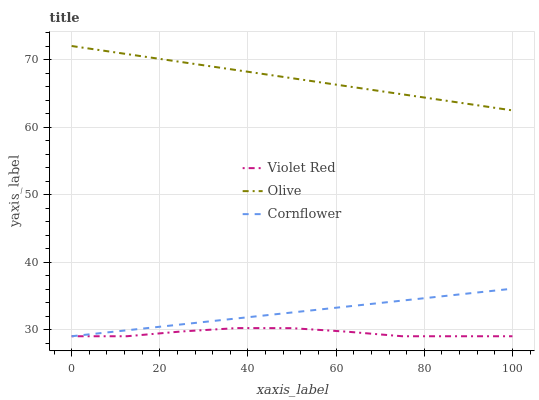Does Violet Red have the minimum area under the curve?
Answer yes or no. Yes. Does Olive have the maximum area under the curve?
Answer yes or no. Yes. Does Cornflower have the minimum area under the curve?
Answer yes or no. No. Does Cornflower have the maximum area under the curve?
Answer yes or no. No. Is Olive the smoothest?
Answer yes or no. Yes. Is Violet Red the roughest?
Answer yes or no. Yes. Is Violet Red the smoothest?
Answer yes or no. No. Is Cornflower the roughest?
Answer yes or no. No. Does Cornflower have the lowest value?
Answer yes or no. Yes. Does Olive have the highest value?
Answer yes or no. Yes. Does Cornflower have the highest value?
Answer yes or no. No. Is Violet Red less than Olive?
Answer yes or no. Yes. Is Olive greater than Cornflower?
Answer yes or no. Yes. Does Violet Red intersect Cornflower?
Answer yes or no. Yes. Is Violet Red less than Cornflower?
Answer yes or no. No. Is Violet Red greater than Cornflower?
Answer yes or no. No. Does Violet Red intersect Olive?
Answer yes or no. No. 